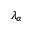<formula> <loc_0><loc_0><loc_500><loc_500>\lambda _ { \alpha }</formula> 